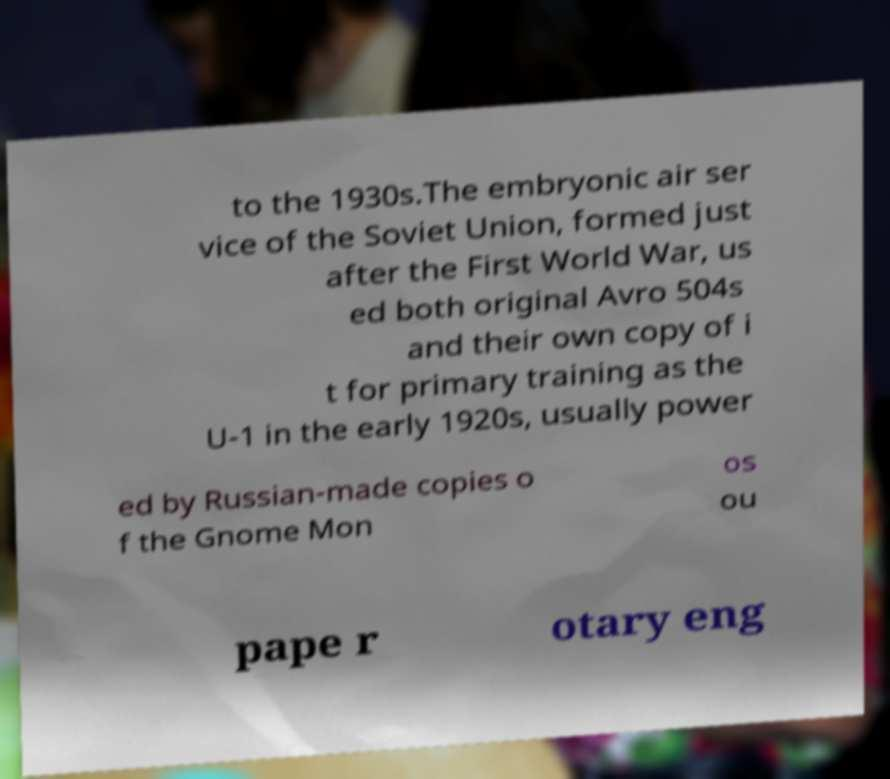Can you accurately transcribe the text from the provided image for me? to the 1930s.The embryonic air ser vice of the Soviet Union, formed just after the First World War, us ed both original Avro 504s and their own copy of i t for primary training as the U-1 in the early 1920s, usually power ed by Russian-made copies o f the Gnome Mon os ou pape r otary eng 